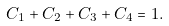<formula> <loc_0><loc_0><loc_500><loc_500>C _ { 1 } + C _ { 2 } + C _ { 3 } + C _ { 4 } = 1 .</formula> 